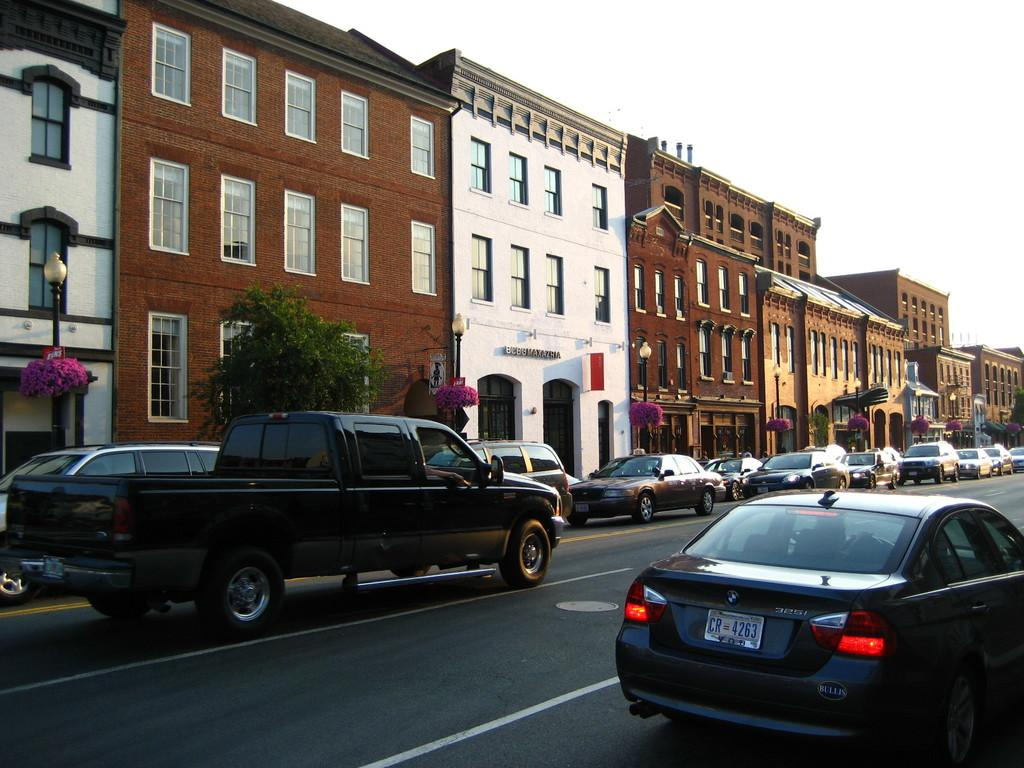What can be seen at the bottom of the image? There are cars on the road at the bottom of the image. What is visible in the background of the image? There are trees, buildings, and the sky visible in the background of the image. What type of zephyr can be seen blowing through the trees in the image? There is no zephyr present in the image; it is a still image with no movement or wind visible. Can you tell me which type of berry is growing on the trees in the image? There are no berries visible on the trees in the image; only leaves and branches can be seen. 